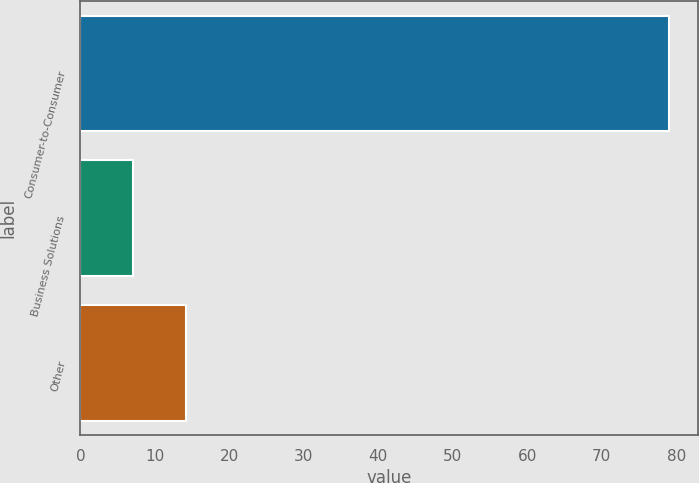Convert chart. <chart><loc_0><loc_0><loc_500><loc_500><bar_chart><fcel>Consumer-to-Consumer<fcel>Business Solutions<fcel>Other<nl><fcel>79<fcel>7<fcel>14.2<nl></chart> 